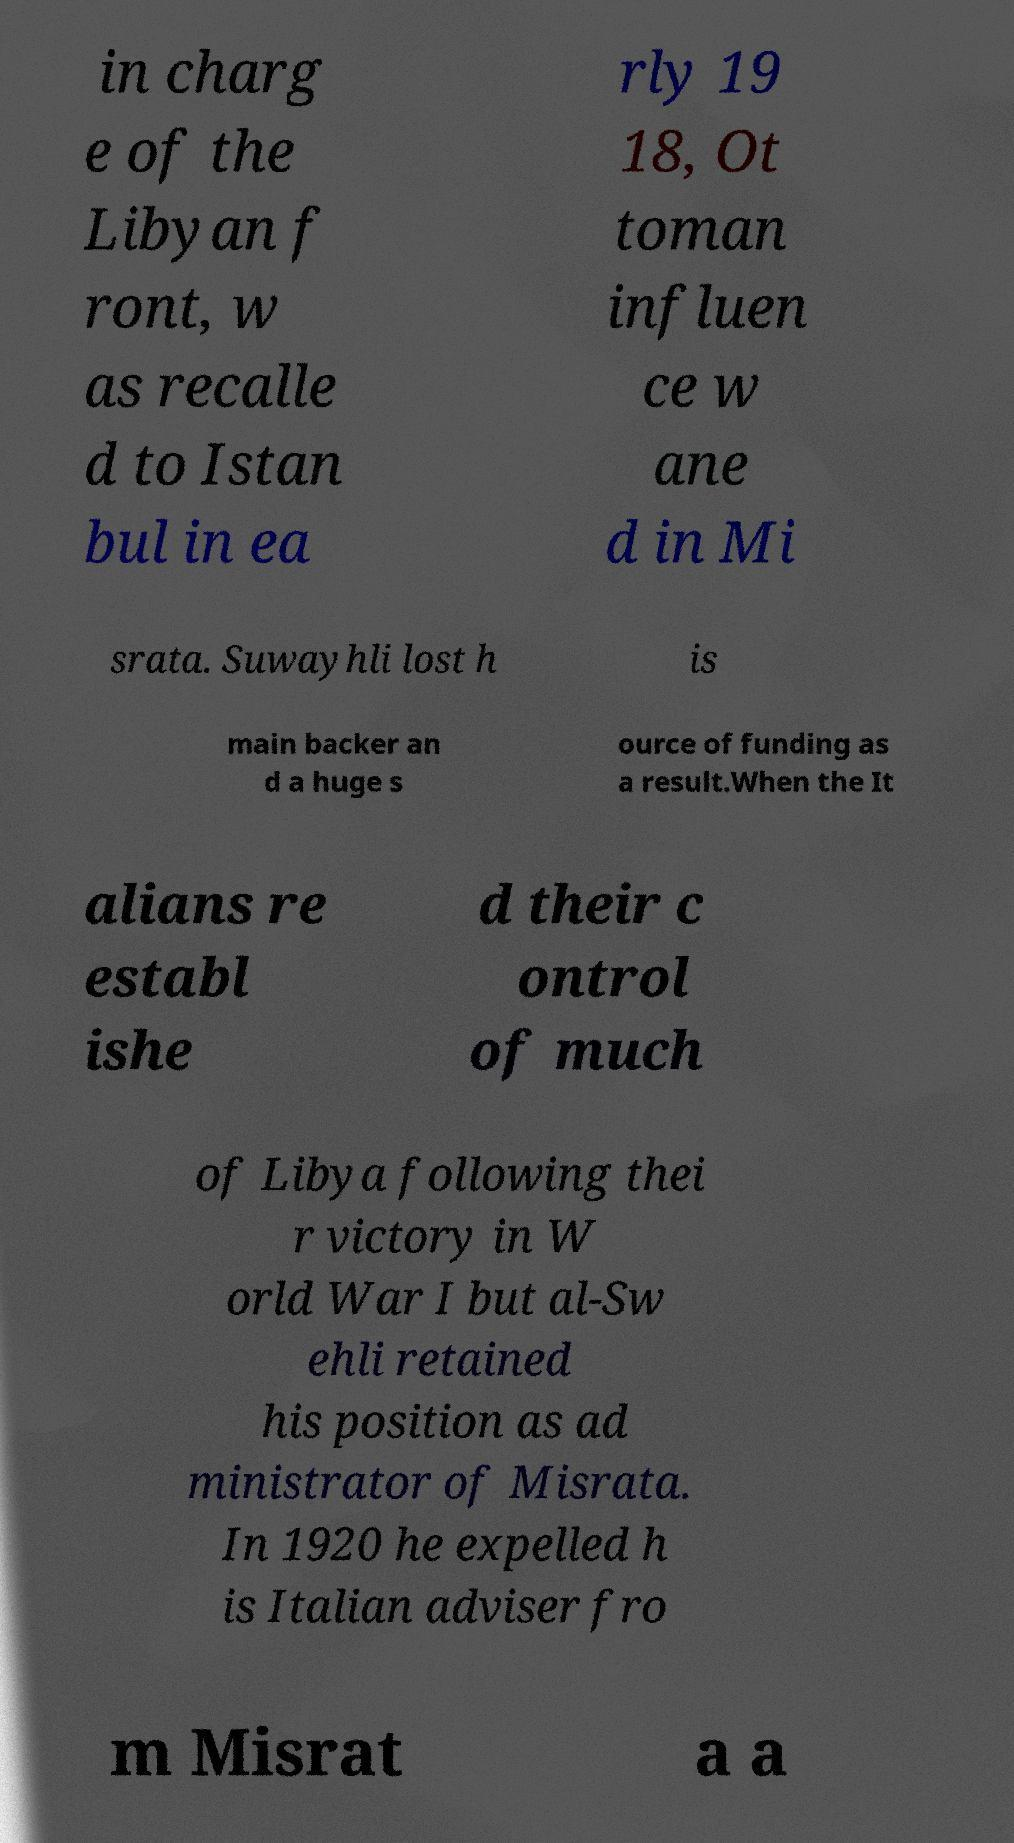Please identify and transcribe the text found in this image. in charg e of the Libyan f ront, w as recalle d to Istan bul in ea rly 19 18, Ot toman influen ce w ane d in Mi srata. Suwayhli lost h is main backer an d a huge s ource of funding as a result.When the It alians re establ ishe d their c ontrol of much of Libya following thei r victory in W orld War I but al-Sw ehli retained his position as ad ministrator of Misrata. In 1920 he expelled h is Italian adviser fro m Misrat a a 